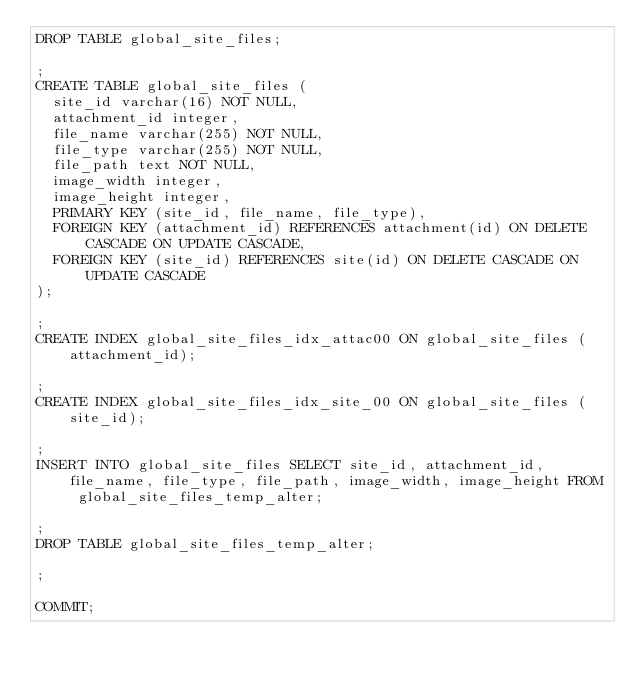<code> <loc_0><loc_0><loc_500><loc_500><_SQL_>DROP TABLE global_site_files;

;
CREATE TABLE global_site_files (
  site_id varchar(16) NOT NULL,
  attachment_id integer,
  file_name varchar(255) NOT NULL,
  file_type varchar(255) NOT NULL,
  file_path text NOT NULL,
  image_width integer,
  image_height integer,
  PRIMARY KEY (site_id, file_name, file_type),
  FOREIGN KEY (attachment_id) REFERENCES attachment(id) ON DELETE CASCADE ON UPDATE CASCADE,
  FOREIGN KEY (site_id) REFERENCES site(id) ON DELETE CASCADE ON UPDATE CASCADE
);

;
CREATE INDEX global_site_files_idx_attac00 ON global_site_files (attachment_id);

;
CREATE INDEX global_site_files_idx_site_00 ON global_site_files (site_id);

;
INSERT INTO global_site_files SELECT site_id, attachment_id, file_name, file_type, file_path, image_width, image_height FROM global_site_files_temp_alter;

;
DROP TABLE global_site_files_temp_alter;

;

COMMIT;

</code> 